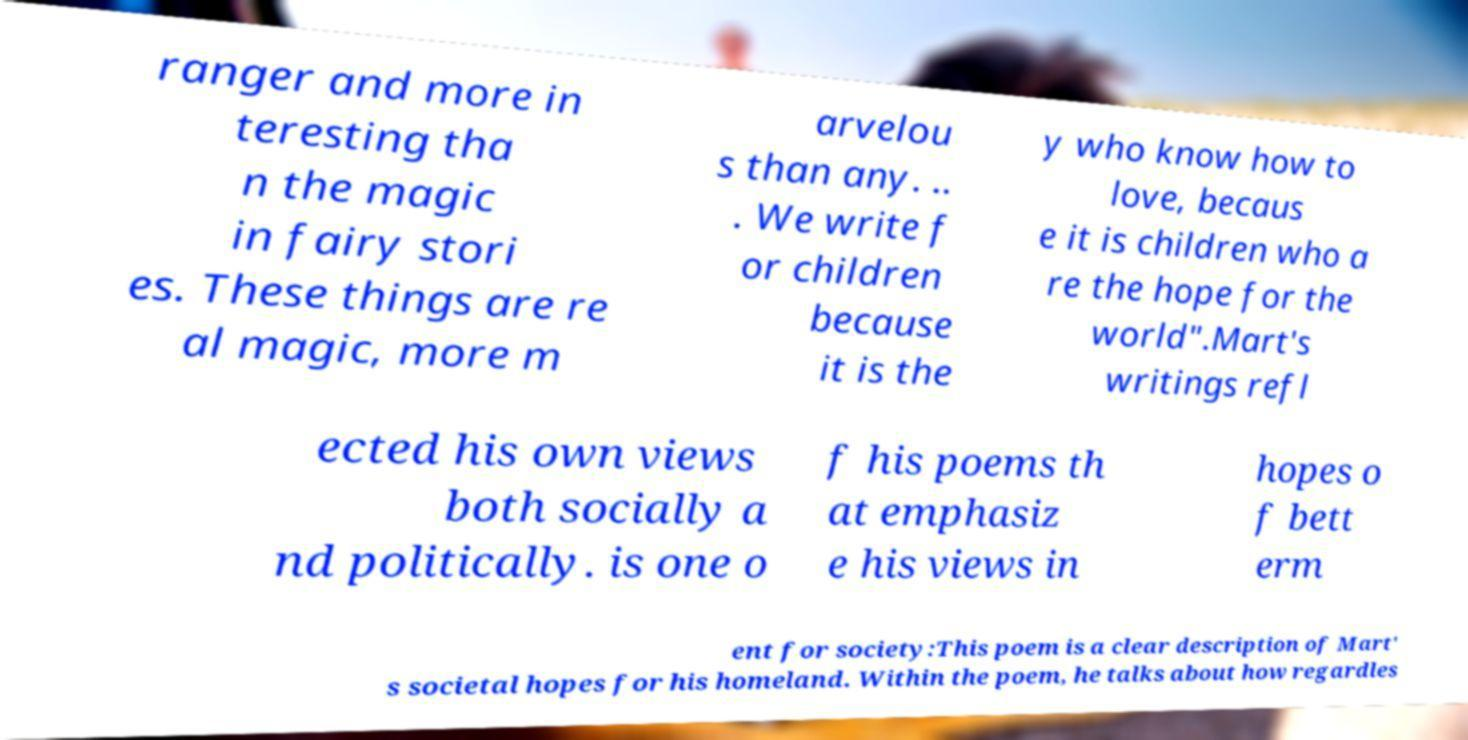There's text embedded in this image that I need extracted. Can you transcribe it verbatim? ranger and more in teresting tha n the magic in fairy stori es. These things are re al magic, more m arvelou s than any. .. . We write f or children because it is the y who know how to love, becaus e it is children who a re the hope for the world".Mart's writings refl ected his own views both socially a nd politically. is one o f his poems th at emphasiz e his views in hopes o f bett erm ent for society:This poem is a clear description of Mart' s societal hopes for his homeland. Within the poem, he talks about how regardles 